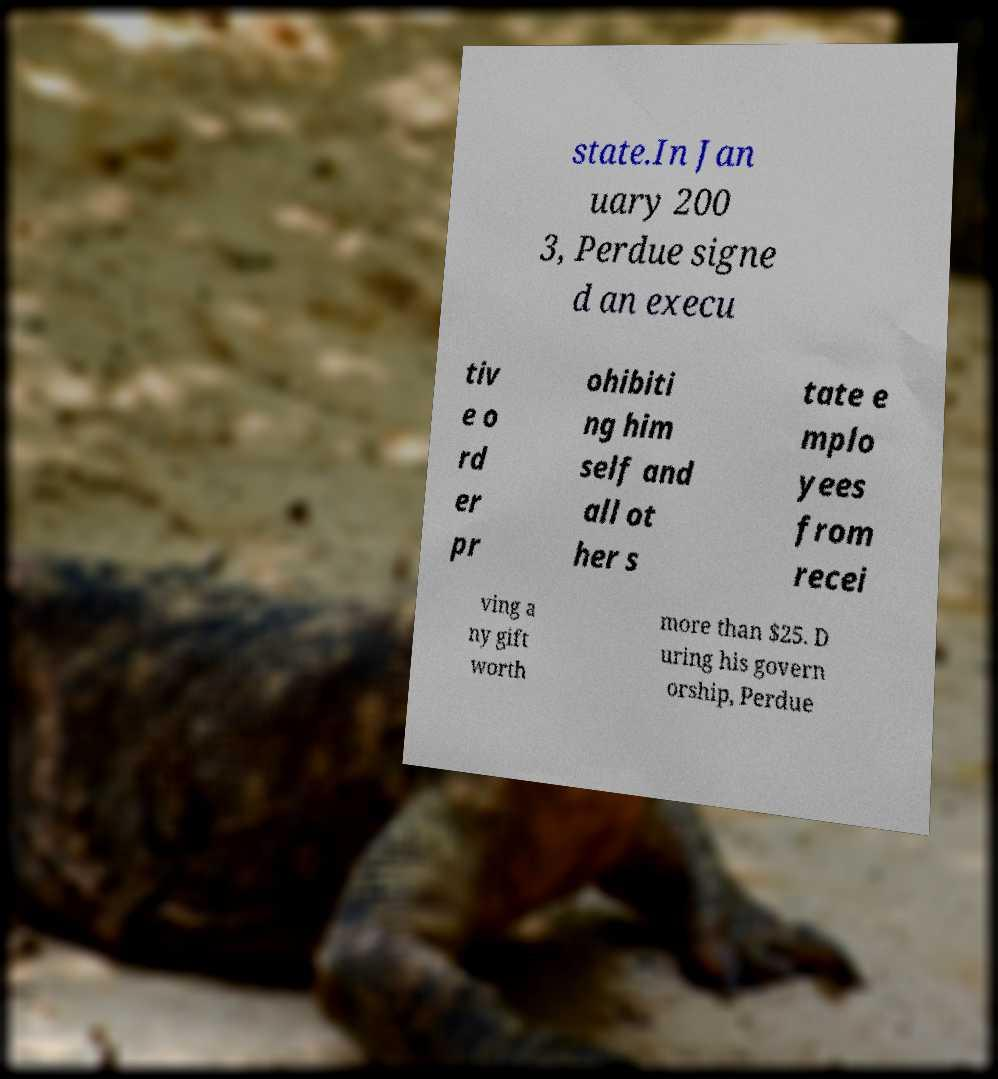Can you accurately transcribe the text from the provided image for me? state.In Jan uary 200 3, Perdue signe d an execu tiv e o rd er pr ohibiti ng him self and all ot her s tate e mplo yees from recei ving a ny gift worth more than $25. D uring his govern orship, Perdue 